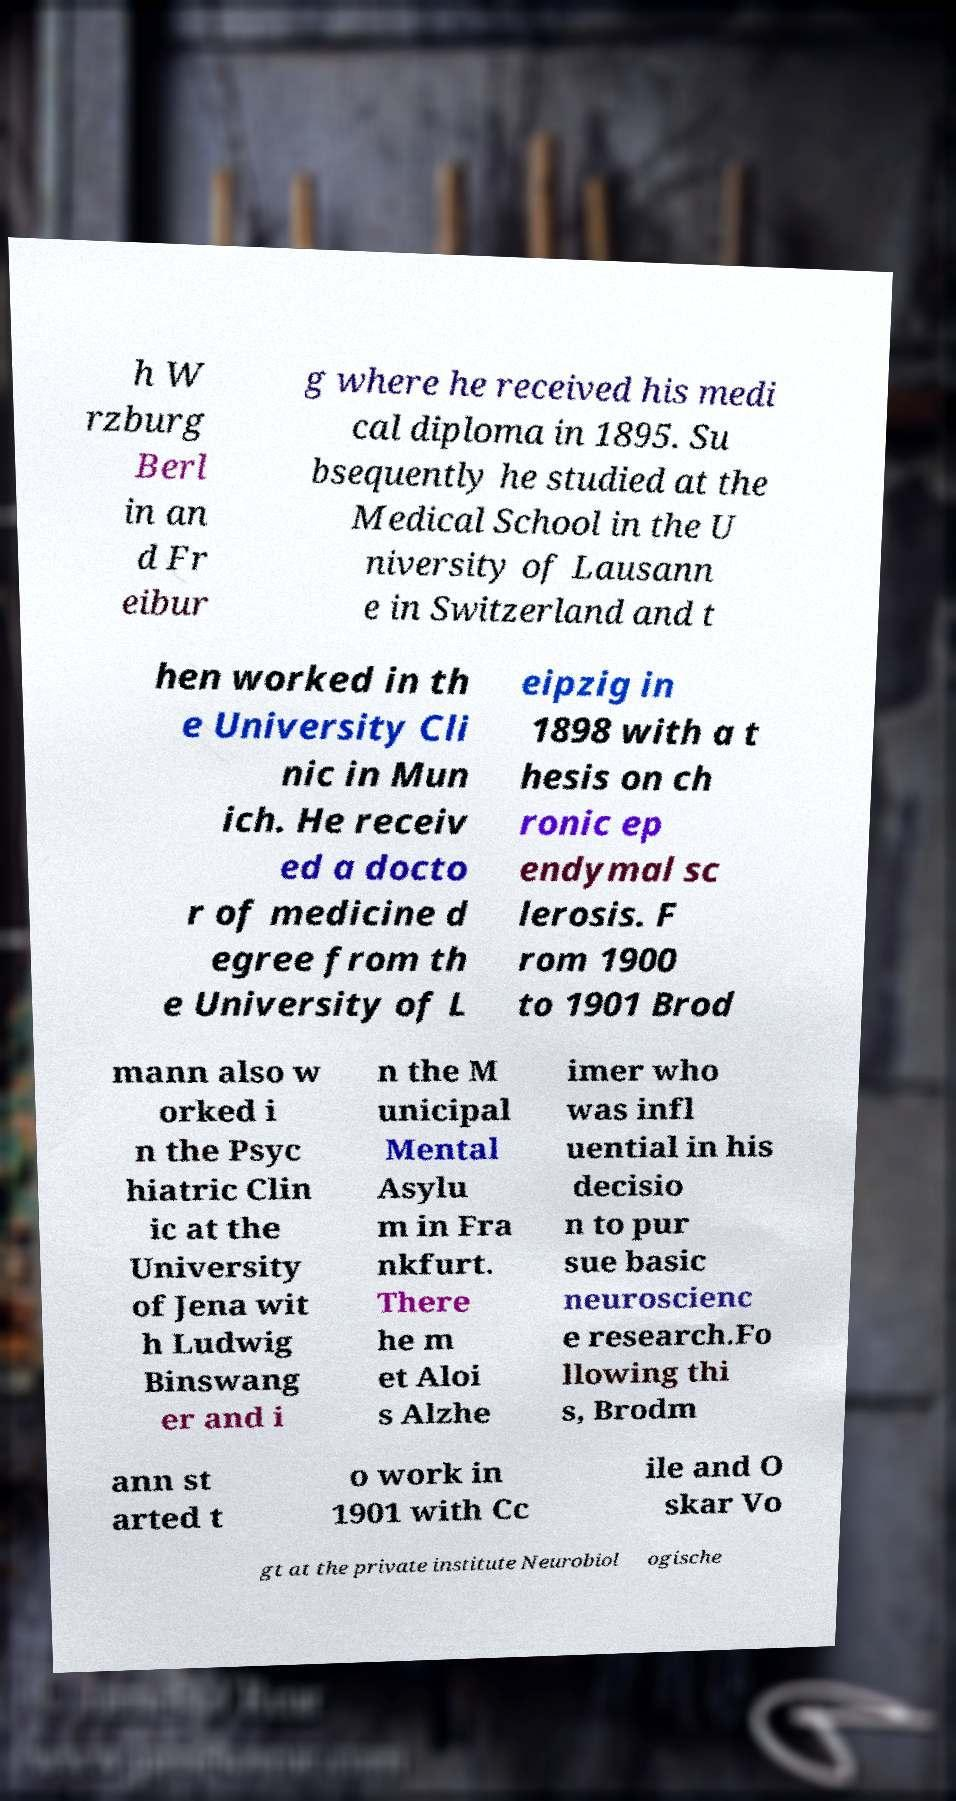For documentation purposes, I need the text within this image transcribed. Could you provide that? h W rzburg Berl in an d Fr eibur g where he received his medi cal diploma in 1895. Su bsequently he studied at the Medical School in the U niversity of Lausann e in Switzerland and t hen worked in th e University Cli nic in Mun ich. He receiv ed a docto r of medicine d egree from th e University of L eipzig in 1898 with a t hesis on ch ronic ep endymal sc lerosis. F rom 1900 to 1901 Brod mann also w orked i n the Psyc hiatric Clin ic at the University of Jena wit h Ludwig Binswang er and i n the M unicipal Mental Asylu m in Fra nkfurt. There he m et Aloi s Alzhe imer who was infl uential in his decisio n to pur sue basic neuroscienc e research.Fo llowing thi s, Brodm ann st arted t o work in 1901 with Cc ile and O skar Vo gt at the private institute Neurobiol ogische 